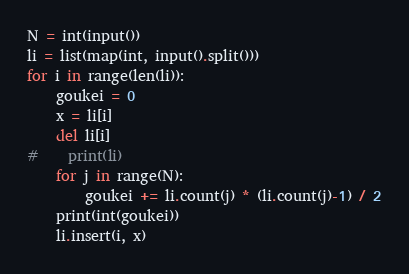Convert code to text. <code><loc_0><loc_0><loc_500><loc_500><_Python_>N = int(input())
li = list(map(int, input().split()))
for i in range(len(li)):
    goukei = 0
    x = li[i]
    del li[i]
#    print(li)
    for j in range(N):
        goukei += li.count(j) * (li.count(j)-1) / 2
    print(int(goukei))
    li.insert(i, x)</code> 